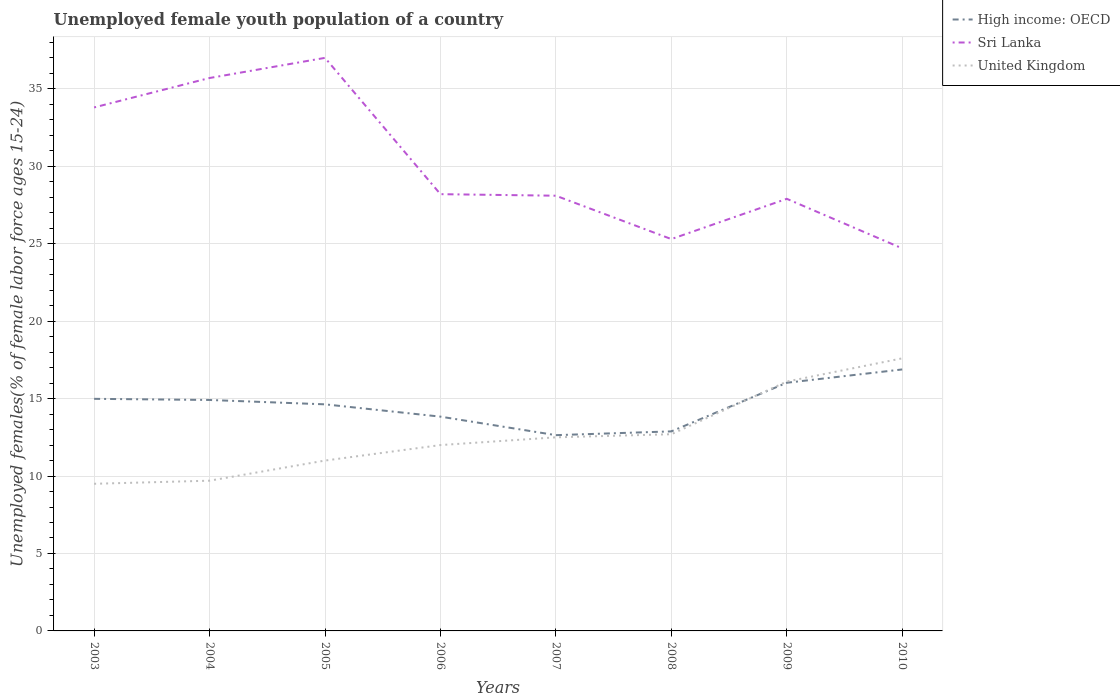Does the line corresponding to United Kingdom intersect with the line corresponding to Sri Lanka?
Offer a terse response. No. Is the number of lines equal to the number of legend labels?
Provide a short and direct response. Yes. Across all years, what is the maximum percentage of unemployed female youth population in United Kingdom?
Provide a succinct answer. 9.5. What is the total percentage of unemployed female youth population in Sri Lanka in the graph?
Make the answer very short. 11. What is the difference between the highest and the second highest percentage of unemployed female youth population in High income: OECD?
Your response must be concise. 4.24. What is the difference between the highest and the lowest percentage of unemployed female youth population in High income: OECD?
Offer a terse response. 5. How many lines are there?
Ensure brevity in your answer.  3. How many years are there in the graph?
Give a very brief answer. 8. What is the difference between two consecutive major ticks on the Y-axis?
Offer a very short reply. 5. Are the values on the major ticks of Y-axis written in scientific E-notation?
Provide a succinct answer. No. Where does the legend appear in the graph?
Give a very brief answer. Top right. What is the title of the graph?
Give a very brief answer. Unemployed female youth population of a country. What is the label or title of the Y-axis?
Make the answer very short. Unemployed females(% of female labor force ages 15-24). What is the Unemployed females(% of female labor force ages 15-24) in High income: OECD in 2003?
Offer a terse response. 14.99. What is the Unemployed females(% of female labor force ages 15-24) in Sri Lanka in 2003?
Make the answer very short. 33.8. What is the Unemployed females(% of female labor force ages 15-24) in United Kingdom in 2003?
Your answer should be compact. 9.5. What is the Unemployed females(% of female labor force ages 15-24) in High income: OECD in 2004?
Your answer should be compact. 14.91. What is the Unemployed females(% of female labor force ages 15-24) of Sri Lanka in 2004?
Provide a succinct answer. 35.7. What is the Unemployed females(% of female labor force ages 15-24) of United Kingdom in 2004?
Provide a succinct answer. 9.7. What is the Unemployed females(% of female labor force ages 15-24) of High income: OECD in 2005?
Offer a terse response. 14.63. What is the Unemployed females(% of female labor force ages 15-24) of Sri Lanka in 2005?
Provide a succinct answer. 37. What is the Unemployed females(% of female labor force ages 15-24) of High income: OECD in 2006?
Ensure brevity in your answer.  13.84. What is the Unemployed females(% of female labor force ages 15-24) in Sri Lanka in 2006?
Give a very brief answer. 28.2. What is the Unemployed females(% of female labor force ages 15-24) of United Kingdom in 2006?
Your answer should be compact. 12. What is the Unemployed females(% of female labor force ages 15-24) in High income: OECD in 2007?
Your answer should be very brief. 12.64. What is the Unemployed females(% of female labor force ages 15-24) in Sri Lanka in 2007?
Make the answer very short. 28.1. What is the Unemployed females(% of female labor force ages 15-24) in High income: OECD in 2008?
Your response must be concise. 12.88. What is the Unemployed females(% of female labor force ages 15-24) in Sri Lanka in 2008?
Your answer should be compact. 25.3. What is the Unemployed females(% of female labor force ages 15-24) of United Kingdom in 2008?
Give a very brief answer. 12.7. What is the Unemployed females(% of female labor force ages 15-24) of High income: OECD in 2009?
Provide a short and direct response. 16.02. What is the Unemployed females(% of female labor force ages 15-24) of Sri Lanka in 2009?
Give a very brief answer. 27.9. What is the Unemployed females(% of female labor force ages 15-24) of United Kingdom in 2009?
Offer a very short reply. 16.1. What is the Unemployed females(% of female labor force ages 15-24) in High income: OECD in 2010?
Provide a short and direct response. 16.88. What is the Unemployed females(% of female labor force ages 15-24) of Sri Lanka in 2010?
Offer a very short reply. 24.7. What is the Unemployed females(% of female labor force ages 15-24) of United Kingdom in 2010?
Ensure brevity in your answer.  17.6. Across all years, what is the maximum Unemployed females(% of female labor force ages 15-24) of High income: OECD?
Your response must be concise. 16.88. Across all years, what is the maximum Unemployed females(% of female labor force ages 15-24) of Sri Lanka?
Offer a terse response. 37. Across all years, what is the maximum Unemployed females(% of female labor force ages 15-24) of United Kingdom?
Your answer should be compact. 17.6. Across all years, what is the minimum Unemployed females(% of female labor force ages 15-24) in High income: OECD?
Provide a succinct answer. 12.64. Across all years, what is the minimum Unemployed females(% of female labor force ages 15-24) in Sri Lanka?
Offer a terse response. 24.7. What is the total Unemployed females(% of female labor force ages 15-24) in High income: OECD in the graph?
Ensure brevity in your answer.  116.79. What is the total Unemployed females(% of female labor force ages 15-24) of Sri Lanka in the graph?
Give a very brief answer. 240.7. What is the total Unemployed females(% of female labor force ages 15-24) of United Kingdom in the graph?
Offer a very short reply. 101.1. What is the difference between the Unemployed females(% of female labor force ages 15-24) in High income: OECD in 2003 and that in 2004?
Provide a short and direct response. 0.07. What is the difference between the Unemployed females(% of female labor force ages 15-24) in High income: OECD in 2003 and that in 2005?
Provide a succinct answer. 0.36. What is the difference between the Unemployed females(% of female labor force ages 15-24) in High income: OECD in 2003 and that in 2006?
Your answer should be very brief. 1.15. What is the difference between the Unemployed females(% of female labor force ages 15-24) of Sri Lanka in 2003 and that in 2006?
Provide a short and direct response. 5.6. What is the difference between the Unemployed females(% of female labor force ages 15-24) of United Kingdom in 2003 and that in 2006?
Ensure brevity in your answer.  -2.5. What is the difference between the Unemployed females(% of female labor force ages 15-24) in High income: OECD in 2003 and that in 2007?
Give a very brief answer. 2.35. What is the difference between the Unemployed females(% of female labor force ages 15-24) in High income: OECD in 2003 and that in 2008?
Offer a very short reply. 2.1. What is the difference between the Unemployed females(% of female labor force ages 15-24) in High income: OECD in 2003 and that in 2009?
Provide a short and direct response. -1.04. What is the difference between the Unemployed females(% of female labor force ages 15-24) of Sri Lanka in 2003 and that in 2009?
Offer a very short reply. 5.9. What is the difference between the Unemployed females(% of female labor force ages 15-24) of United Kingdom in 2003 and that in 2009?
Offer a terse response. -6.6. What is the difference between the Unemployed females(% of female labor force ages 15-24) in High income: OECD in 2003 and that in 2010?
Your answer should be very brief. -1.9. What is the difference between the Unemployed females(% of female labor force ages 15-24) of Sri Lanka in 2003 and that in 2010?
Offer a very short reply. 9.1. What is the difference between the Unemployed females(% of female labor force ages 15-24) in United Kingdom in 2003 and that in 2010?
Give a very brief answer. -8.1. What is the difference between the Unemployed females(% of female labor force ages 15-24) of High income: OECD in 2004 and that in 2005?
Give a very brief answer. 0.28. What is the difference between the Unemployed females(% of female labor force ages 15-24) in United Kingdom in 2004 and that in 2005?
Your answer should be very brief. -1.3. What is the difference between the Unemployed females(% of female labor force ages 15-24) of High income: OECD in 2004 and that in 2006?
Your answer should be compact. 1.08. What is the difference between the Unemployed females(% of female labor force ages 15-24) in United Kingdom in 2004 and that in 2006?
Offer a very short reply. -2.3. What is the difference between the Unemployed females(% of female labor force ages 15-24) of High income: OECD in 2004 and that in 2007?
Ensure brevity in your answer.  2.27. What is the difference between the Unemployed females(% of female labor force ages 15-24) of Sri Lanka in 2004 and that in 2007?
Provide a succinct answer. 7.6. What is the difference between the Unemployed females(% of female labor force ages 15-24) in High income: OECD in 2004 and that in 2008?
Offer a very short reply. 2.03. What is the difference between the Unemployed females(% of female labor force ages 15-24) in Sri Lanka in 2004 and that in 2008?
Make the answer very short. 10.4. What is the difference between the Unemployed females(% of female labor force ages 15-24) of High income: OECD in 2004 and that in 2009?
Your answer should be compact. -1.11. What is the difference between the Unemployed females(% of female labor force ages 15-24) of Sri Lanka in 2004 and that in 2009?
Your response must be concise. 7.8. What is the difference between the Unemployed females(% of female labor force ages 15-24) of United Kingdom in 2004 and that in 2009?
Offer a terse response. -6.4. What is the difference between the Unemployed females(% of female labor force ages 15-24) in High income: OECD in 2004 and that in 2010?
Ensure brevity in your answer.  -1.97. What is the difference between the Unemployed females(% of female labor force ages 15-24) of Sri Lanka in 2004 and that in 2010?
Your answer should be very brief. 11. What is the difference between the Unemployed females(% of female labor force ages 15-24) in United Kingdom in 2004 and that in 2010?
Your answer should be compact. -7.9. What is the difference between the Unemployed females(% of female labor force ages 15-24) of High income: OECD in 2005 and that in 2006?
Your answer should be very brief. 0.79. What is the difference between the Unemployed females(% of female labor force ages 15-24) of United Kingdom in 2005 and that in 2006?
Your response must be concise. -1. What is the difference between the Unemployed females(% of female labor force ages 15-24) of High income: OECD in 2005 and that in 2007?
Offer a very short reply. 1.99. What is the difference between the Unemployed females(% of female labor force ages 15-24) of Sri Lanka in 2005 and that in 2007?
Offer a terse response. 8.9. What is the difference between the Unemployed females(% of female labor force ages 15-24) of United Kingdom in 2005 and that in 2007?
Provide a succinct answer. -1.5. What is the difference between the Unemployed females(% of female labor force ages 15-24) in High income: OECD in 2005 and that in 2008?
Provide a succinct answer. 1.75. What is the difference between the Unemployed females(% of female labor force ages 15-24) of Sri Lanka in 2005 and that in 2008?
Your response must be concise. 11.7. What is the difference between the Unemployed females(% of female labor force ages 15-24) in United Kingdom in 2005 and that in 2008?
Provide a short and direct response. -1.7. What is the difference between the Unemployed females(% of female labor force ages 15-24) in High income: OECD in 2005 and that in 2009?
Your response must be concise. -1.39. What is the difference between the Unemployed females(% of female labor force ages 15-24) in High income: OECD in 2005 and that in 2010?
Provide a succinct answer. -2.25. What is the difference between the Unemployed females(% of female labor force ages 15-24) of Sri Lanka in 2005 and that in 2010?
Provide a succinct answer. 12.3. What is the difference between the Unemployed females(% of female labor force ages 15-24) in High income: OECD in 2006 and that in 2007?
Make the answer very short. 1.2. What is the difference between the Unemployed females(% of female labor force ages 15-24) in United Kingdom in 2006 and that in 2007?
Make the answer very short. -0.5. What is the difference between the Unemployed females(% of female labor force ages 15-24) in High income: OECD in 2006 and that in 2008?
Give a very brief answer. 0.95. What is the difference between the Unemployed females(% of female labor force ages 15-24) of High income: OECD in 2006 and that in 2009?
Make the answer very short. -2.19. What is the difference between the Unemployed females(% of female labor force ages 15-24) of Sri Lanka in 2006 and that in 2009?
Your answer should be very brief. 0.3. What is the difference between the Unemployed females(% of female labor force ages 15-24) of United Kingdom in 2006 and that in 2009?
Your response must be concise. -4.1. What is the difference between the Unemployed females(% of female labor force ages 15-24) of High income: OECD in 2006 and that in 2010?
Make the answer very short. -3.05. What is the difference between the Unemployed females(% of female labor force ages 15-24) in Sri Lanka in 2006 and that in 2010?
Keep it short and to the point. 3.5. What is the difference between the Unemployed females(% of female labor force ages 15-24) of High income: OECD in 2007 and that in 2008?
Give a very brief answer. -0.24. What is the difference between the Unemployed females(% of female labor force ages 15-24) of High income: OECD in 2007 and that in 2009?
Ensure brevity in your answer.  -3.38. What is the difference between the Unemployed females(% of female labor force ages 15-24) in Sri Lanka in 2007 and that in 2009?
Offer a very short reply. 0.2. What is the difference between the Unemployed females(% of female labor force ages 15-24) in United Kingdom in 2007 and that in 2009?
Make the answer very short. -3.6. What is the difference between the Unemployed females(% of female labor force ages 15-24) in High income: OECD in 2007 and that in 2010?
Your answer should be compact. -4.24. What is the difference between the Unemployed females(% of female labor force ages 15-24) in Sri Lanka in 2007 and that in 2010?
Provide a short and direct response. 3.4. What is the difference between the Unemployed females(% of female labor force ages 15-24) in United Kingdom in 2007 and that in 2010?
Your answer should be compact. -5.1. What is the difference between the Unemployed females(% of female labor force ages 15-24) in High income: OECD in 2008 and that in 2009?
Your response must be concise. -3.14. What is the difference between the Unemployed females(% of female labor force ages 15-24) in Sri Lanka in 2008 and that in 2009?
Your answer should be very brief. -2.6. What is the difference between the Unemployed females(% of female labor force ages 15-24) of High income: OECD in 2008 and that in 2010?
Ensure brevity in your answer.  -4. What is the difference between the Unemployed females(% of female labor force ages 15-24) in High income: OECD in 2009 and that in 2010?
Make the answer very short. -0.86. What is the difference between the Unemployed females(% of female labor force ages 15-24) in Sri Lanka in 2009 and that in 2010?
Keep it short and to the point. 3.2. What is the difference between the Unemployed females(% of female labor force ages 15-24) of High income: OECD in 2003 and the Unemployed females(% of female labor force ages 15-24) of Sri Lanka in 2004?
Your answer should be compact. -20.71. What is the difference between the Unemployed females(% of female labor force ages 15-24) in High income: OECD in 2003 and the Unemployed females(% of female labor force ages 15-24) in United Kingdom in 2004?
Offer a terse response. 5.29. What is the difference between the Unemployed females(% of female labor force ages 15-24) in Sri Lanka in 2003 and the Unemployed females(% of female labor force ages 15-24) in United Kingdom in 2004?
Offer a terse response. 24.1. What is the difference between the Unemployed females(% of female labor force ages 15-24) of High income: OECD in 2003 and the Unemployed females(% of female labor force ages 15-24) of Sri Lanka in 2005?
Provide a short and direct response. -22.01. What is the difference between the Unemployed females(% of female labor force ages 15-24) in High income: OECD in 2003 and the Unemployed females(% of female labor force ages 15-24) in United Kingdom in 2005?
Keep it short and to the point. 3.99. What is the difference between the Unemployed females(% of female labor force ages 15-24) of Sri Lanka in 2003 and the Unemployed females(% of female labor force ages 15-24) of United Kingdom in 2005?
Offer a very short reply. 22.8. What is the difference between the Unemployed females(% of female labor force ages 15-24) of High income: OECD in 2003 and the Unemployed females(% of female labor force ages 15-24) of Sri Lanka in 2006?
Your response must be concise. -13.21. What is the difference between the Unemployed females(% of female labor force ages 15-24) of High income: OECD in 2003 and the Unemployed females(% of female labor force ages 15-24) of United Kingdom in 2006?
Give a very brief answer. 2.99. What is the difference between the Unemployed females(% of female labor force ages 15-24) of Sri Lanka in 2003 and the Unemployed females(% of female labor force ages 15-24) of United Kingdom in 2006?
Offer a very short reply. 21.8. What is the difference between the Unemployed females(% of female labor force ages 15-24) of High income: OECD in 2003 and the Unemployed females(% of female labor force ages 15-24) of Sri Lanka in 2007?
Offer a terse response. -13.11. What is the difference between the Unemployed females(% of female labor force ages 15-24) in High income: OECD in 2003 and the Unemployed females(% of female labor force ages 15-24) in United Kingdom in 2007?
Offer a very short reply. 2.49. What is the difference between the Unemployed females(% of female labor force ages 15-24) in Sri Lanka in 2003 and the Unemployed females(% of female labor force ages 15-24) in United Kingdom in 2007?
Your response must be concise. 21.3. What is the difference between the Unemployed females(% of female labor force ages 15-24) of High income: OECD in 2003 and the Unemployed females(% of female labor force ages 15-24) of Sri Lanka in 2008?
Provide a short and direct response. -10.31. What is the difference between the Unemployed females(% of female labor force ages 15-24) of High income: OECD in 2003 and the Unemployed females(% of female labor force ages 15-24) of United Kingdom in 2008?
Offer a terse response. 2.29. What is the difference between the Unemployed females(% of female labor force ages 15-24) in Sri Lanka in 2003 and the Unemployed females(% of female labor force ages 15-24) in United Kingdom in 2008?
Provide a succinct answer. 21.1. What is the difference between the Unemployed females(% of female labor force ages 15-24) of High income: OECD in 2003 and the Unemployed females(% of female labor force ages 15-24) of Sri Lanka in 2009?
Your answer should be very brief. -12.91. What is the difference between the Unemployed females(% of female labor force ages 15-24) of High income: OECD in 2003 and the Unemployed females(% of female labor force ages 15-24) of United Kingdom in 2009?
Your answer should be very brief. -1.11. What is the difference between the Unemployed females(% of female labor force ages 15-24) in Sri Lanka in 2003 and the Unemployed females(% of female labor force ages 15-24) in United Kingdom in 2009?
Your answer should be compact. 17.7. What is the difference between the Unemployed females(% of female labor force ages 15-24) of High income: OECD in 2003 and the Unemployed females(% of female labor force ages 15-24) of Sri Lanka in 2010?
Give a very brief answer. -9.71. What is the difference between the Unemployed females(% of female labor force ages 15-24) of High income: OECD in 2003 and the Unemployed females(% of female labor force ages 15-24) of United Kingdom in 2010?
Make the answer very short. -2.61. What is the difference between the Unemployed females(% of female labor force ages 15-24) of Sri Lanka in 2003 and the Unemployed females(% of female labor force ages 15-24) of United Kingdom in 2010?
Keep it short and to the point. 16.2. What is the difference between the Unemployed females(% of female labor force ages 15-24) of High income: OECD in 2004 and the Unemployed females(% of female labor force ages 15-24) of Sri Lanka in 2005?
Your answer should be very brief. -22.09. What is the difference between the Unemployed females(% of female labor force ages 15-24) in High income: OECD in 2004 and the Unemployed females(% of female labor force ages 15-24) in United Kingdom in 2005?
Provide a succinct answer. 3.91. What is the difference between the Unemployed females(% of female labor force ages 15-24) of Sri Lanka in 2004 and the Unemployed females(% of female labor force ages 15-24) of United Kingdom in 2005?
Your answer should be compact. 24.7. What is the difference between the Unemployed females(% of female labor force ages 15-24) of High income: OECD in 2004 and the Unemployed females(% of female labor force ages 15-24) of Sri Lanka in 2006?
Provide a succinct answer. -13.29. What is the difference between the Unemployed females(% of female labor force ages 15-24) of High income: OECD in 2004 and the Unemployed females(% of female labor force ages 15-24) of United Kingdom in 2006?
Your answer should be compact. 2.91. What is the difference between the Unemployed females(% of female labor force ages 15-24) of Sri Lanka in 2004 and the Unemployed females(% of female labor force ages 15-24) of United Kingdom in 2006?
Give a very brief answer. 23.7. What is the difference between the Unemployed females(% of female labor force ages 15-24) of High income: OECD in 2004 and the Unemployed females(% of female labor force ages 15-24) of Sri Lanka in 2007?
Your answer should be very brief. -13.19. What is the difference between the Unemployed females(% of female labor force ages 15-24) in High income: OECD in 2004 and the Unemployed females(% of female labor force ages 15-24) in United Kingdom in 2007?
Your response must be concise. 2.41. What is the difference between the Unemployed females(% of female labor force ages 15-24) of Sri Lanka in 2004 and the Unemployed females(% of female labor force ages 15-24) of United Kingdom in 2007?
Provide a succinct answer. 23.2. What is the difference between the Unemployed females(% of female labor force ages 15-24) of High income: OECD in 2004 and the Unemployed females(% of female labor force ages 15-24) of Sri Lanka in 2008?
Keep it short and to the point. -10.39. What is the difference between the Unemployed females(% of female labor force ages 15-24) in High income: OECD in 2004 and the Unemployed females(% of female labor force ages 15-24) in United Kingdom in 2008?
Offer a very short reply. 2.21. What is the difference between the Unemployed females(% of female labor force ages 15-24) of Sri Lanka in 2004 and the Unemployed females(% of female labor force ages 15-24) of United Kingdom in 2008?
Offer a very short reply. 23. What is the difference between the Unemployed females(% of female labor force ages 15-24) of High income: OECD in 2004 and the Unemployed females(% of female labor force ages 15-24) of Sri Lanka in 2009?
Your answer should be compact. -12.99. What is the difference between the Unemployed females(% of female labor force ages 15-24) of High income: OECD in 2004 and the Unemployed females(% of female labor force ages 15-24) of United Kingdom in 2009?
Offer a terse response. -1.19. What is the difference between the Unemployed females(% of female labor force ages 15-24) of Sri Lanka in 2004 and the Unemployed females(% of female labor force ages 15-24) of United Kingdom in 2009?
Give a very brief answer. 19.6. What is the difference between the Unemployed females(% of female labor force ages 15-24) in High income: OECD in 2004 and the Unemployed females(% of female labor force ages 15-24) in Sri Lanka in 2010?
Your response must be concise. -9.79. What is the difference between the Unemployed females(% of female labor force ages 15-24) in High income: OECD in 2004 and the Unemployed females(% of female labor force ages 15-24) in United Kingdom in 2010?
Your answer should be very brief. -2.69. What is the difference between the Unemployed females(% of female labor force ages 15-24) of High income: OECD in 2005 and the Unemployed females(% of female labor force ages 15-24) of Sri Lanka in 2006?
Your answer should be very brief. -13.57. What is the difference between the Unemployed females(% of female labor force ages 15-24) of High income: OECD in 2005 and the Unemployed females(% of female labor force ages 15-24) of United Kingdom in 2006?
Keep it short and to the point. 2.63. What is the difference between the Unemployed females(% of female labor force ages 15-24) in High income: OECD in 2005 and the Unemployed females(% of female labor force ages 15-24) in Sri Lanka in 2007?
Your response must be concise. -13.47. What is the difference between the Unemployed females(% of female labor force ages 15-24) of High income: OECD in 2005 and the Unemployed females(% of female labor force ages 15-24) of United Kingdom in 2007?
Give a very brief answer. 2.13. What is the difference between the Unemployed females(% of female labor force ages 15-24) of Sri Lanka in 2005 and the Unemployed females(% of female labor force ages 15-24) of United Kingdom in 2007?
Make the answer very short. 24.5. What is the difference between the Unemployed females(% of female labor force ages 15-24) of High income: OECD in 2005 and the Unemployed females(% of female labor force ages 15-24) of Sri Lanka in 2008?
Offer a very short reply. -10.67. What is the difference between the Unemployed females(% of female labor force ages 15-24) in High income: OECD in 2005 and the Unemployed females(% of female labor force ages 15-24) in United Kingdom in 2008?
Provide a succinct answer. 1.93. What is the difference between the Unemployed females(% of female labor force ages 15-24) of Sri Lanka in 2005 and the Unemployed females(% of female labor force ages 15-24) of United Kingdom in 2008?
Your answer should be compact. 24.3. What is the difference between the Unemployed females(% of female labor force ages 15-24) of High income: OECD in 2005 and the Unemployed females(% of female labor force ages 15-24) of Sri Lanka in 2009?
Provide a succinct answer. -13.27. What is the difference between the Unemployed females(% of female labor force ages 15-24) in High income: OECD in 2005 and the Unemployed females(% of female labor force ages 15-24) in United Kingdom in 2009?
Your answer should be very brief. -1.47. What is the difference between the Unemployed females(% of female labor force ages 15-24) in Sri Lanka in 2005 and the Unemployed females(% of female labor force ages 15-24) in United Kingdom in 2009?
Keep it short and to the point. 20.9. What is the difference between the Unemployed females(% of female labor force ages 15-24) in High income: OECD in 2005 and the Unemployed females(% of female labor force ages 15-24) in Sri Lanka in 2010?
Offer a terse response. -10.07. What is the difference between the Unemployed females(% of female labor force ages 15-24) in High income: OECD in 2005 and the Unemployed females(% of female labor force ages 15-24) in United Kingdom in 2010?
Provide a short and direct response. -2.97. What is the difference between the Unemployed females(% of female labor force ages 15-24) in Sri Lanka in 2005 and the Unemployed females(% of female labor force ages 15-24) in United Kingdom in 2010?
Give a very brief answer. 19.4. What is the difference between the Unemployed females(% of female labor force ages 15-24) in High income: OECD in 2006 and the Unemployed females(% of female labor force ages 15-24) in Sri Lanka in 2007?
Make the answer very short. -14.26. What is the difference between the Unemployed females(% of female labor force ages 15-24) in High income: OECD in 2006 and the Unemployed females(% of female labor force ages 15-24) in United Kingdom in 2007?
Make the answer very short. 1.34. What is the difference between the Unemployed females(% of female labor force ages 15-24) of Sri Lanka in 2006 and the Unemployed females(% of female labor force ages 15-24) of United Kingdom in 2007?
Provide a succinct answer. 15.7. What is the difference between the Unemployed females(% of female labor force ages 15-24) in High income: OECD in 2006 and the Unemployed females(% of female labor force ages 15-24) in Sri Lanka in 2008?
Keep it short and to the point. -11.46. What is the difference between the Unemployed females(% of female labor force ages 15-24) in High income: OECD in 2006 and the Unemployed females(% of female labor force ages 15-24) in United Kingdom in 2008?
Your response must be concise. 1.14. What is the difference between the Unemployed females(% of female labor force ages 15-24) of Sri Lanka in 2006 and the Unemployed females(% of female labor force ages 15-24) of United Kingdom in 2008?
Provide a succinct answer. 15.5. What is the difference between the Unemployed females(% of female labor force ages 15-24) of High income: OECD in 2006 and the Unemployed females(% of female labor force ages 15-24) of Sri Lanka in 2009?
Make the answer very short. -14.06. What is the difference between the Unemployed females(% of female labor force ages 15-24) of High income: OECD in 2006 and the Unemployed females(% of female labor force ages 15-24) of United Kingdom in 2009?
Your answer should be very brief. -2.26. What is the difference between the Unemployed females(% of female labor force ages 15-24) in Sri Lanka in 2006 and the Unemployed females(% of female labor force ages 15-24) in United Kingdom in 2009?
Give a very brief answer. 12.1. What is the difference between the Unemployed females(% of female labor force ages 15-24) of High income: OECD in 2006 and the Unemployed females(% of female labor force ages 15-24) of Sri Lanka in 2010?
Make the answer very short. -10.86. What is the difference between the Unemployed females(% of female labor force ages 15-24) in High income: OECD in 2006 and the Unemployed females(% of female labor force ages 15-24) in United Kingdom in 2010?
Your answer should be very brief. -3.76. What is the difference between the Unemployed females(% of female labor force ages 15-24) of Sri Lanka in 2006 and the Unemployed females(% of female labor force ages 15-24) of United Kingdom in 2010?
Your answer should be very brief. 10.6. What is the difference between the Unemployed females(% of female labor force ages 15-24) in High income: OECD in 2007 and the Unemployed females(% of female labor force ages 15-24) in Sri Lanka in 2008?
Give a very brief answer. -12.66. What is the difference between the Unemployed females(% of female labor force ages 15-24) of High income: OECD in 2007 and the Unemployed females(% of female labor force ages 15-24) of United Kingdom in 2008?
Ensure brevity in your answer.  -0.06. What is the difference between the Unemployed females(% of female labor force ages 15-24) in Sri Lanka in 2007 and the Unemployed females(% of female labor force ages 15-24) in United Kingdom in 2008?
Ensure brevity in your answer.  15.4. What is the difference between the Unemployed females(% of female labor force ages 15-24) in High income: OECD in 2007 and the Unemployed females(% of female labor force ages 15-24) in Sri Lanka in 2009?
Keep it short and to the point. -15.26. What is the difference between the Unemployed females(% of female labor force ages 15-24) of High income: OECD in 2007 and the Unemployed females(% of female labor force ages 15-24) of United Kingdom in 2009?
Make the answer very short. -3.46. What is the difference between the Unemployed females(% of female labor force ages 15-24) in Sri Lanka in 2007 and the Unemployed females(% of female labor force ages 15-24) in United Kingdom in 2009?
Your answer should be very brief. 12. What is the difference between the Unemployed females(% of female labor force ages 15-24) in High income: OECD in 2007 and the Unemployed females(% of female labor force ages 15-24) in Sri Lanka in 2010?
Provide a succinct answer. -12.06. What is the difference between the Unemployed females(% of female labor force ages 15-24) in High income: OECD in 2007 and the Unemployed females(% of female labor force ages 15-24) in United Kingdom in 2010?
Your answer should be compact. -4.96. What is the difference between the Unemployed females(% of female labor force ages 15-24) of High income: OECD in 2008 and the Unemployed females(% of female labor force ages 15-24) of Sri Lanka in 2009?
Your answer should be very brief. -15.02. What is the difference between the Unemployed females(% of female labor force ages 15-24) of High income: OECD in 2008 and the Unemployed females(% of female labor force ages 15-24) of United Kingdom in 2009?
Your answer should be compact. -3.22. What is the difference between the Unemployed females(% of female labor force ages 15-24) in Sri Lanka in 2008 and the Unemployed females(% of female labor force ages 15-24) in United Kingdom in 2009?
Provide a short and direct response. 9.2. What is the difference between the Unemployed females(% of female labor force ages 15-24) of High income: OECD in 2008 and the Unemployed females(% of female labor force ages 15-24) of Sri Lanka in 2010?
Provide a short and direct response. -11.82. What is the difference between the Unemployed females(% of female labor force ages 15-24) of High income: OECD in 2008 and the Unemployed females(% of female labor force ages 15-24) of United Kingdom in 2010?
Your response must be concise. -4.72. What is the difference between the Unemployed females(% of female labor force ages 15-24) of High income: OECD in 2009 and the Unemployed females(% of female labor force ages 15-24) of Sri Lanka in 2010?
Your answer should be compact. -8.68. What is the difference between the Unemployed females(% of female labor force ages 15-24) of High income: OECD in 2009 and the Unemployed females(% of female labor force ages 15-24) of United Kingdom in 2010?
Your answer should be compact. -1.58. What is the difference between the Unemployed females(% of female labor force ages 15-24) in Sri Lanka in 2009 and the Unemployed females(% of female labor force ages 15-24) in United Kingdom in 2010?
Give a very brief answer. 10.3. What is the average Unemployed females(% of female labor force ages 15-24) in High income: OECD per year?
Make the answer very short. 14.6. What is the average Unemployed females(% of female labor force ages 15-24) of Sri Lanka per year?
Your answer should be compact. 30.09. What is the average Unemployed females(% of female labor force ages 15-24) in United Kingdom per year?
Provide a succinct answer. 12.64. In the year 2003, what is the difference between the Unemployed females(% of female labor force ages 15-24) in High income: OECD and Unemployed females(% of female labor force ages 15-24) in Sri Lanka?
Offer a terse response. -18.81. In the year 2003, what is the difference between the Unemployed females(% of female labor force ages 15-24) in High income: OECD and Unemployed females(% of female labor force ages 15-24) in United Kingdom?
Offer a terse response. 5.49. In the year 2003, what is the difference between the Unemployed females(% of female labor force ages 15-24) in Sri Lanka and Unemployed females(% of female labor force ages 15-24) in United Kingdom?
Provide a short and direct response. 24.3. In the year 2004, what is the difference between the Unemployed females(% of female labor force ages 15-24) in High income: OECD and Unemployed females(% of female labor force ages 15-24) in Sri Lanka?
Make the answer very short. -20.79. In the year 2004, what is the difference between the Unemployed females(% of female labor force ages 15-24) in High income: OECD and Unemployed females(% of female labor force ages 15-24) in United Kingdom?
Your response must be concise. 5.21. In the year 2004, what is the difference between the Unemployed females(% of female labor force ages 15-24) in Sri Lanka and Unemployed females(% of female labor force ages 15-24) in United Kingdom?
Your answer should be very brief. 26. In the year 2005, what is the difference between the Unemployed females(% of female labor force ages 15-24) of High income: OECD and Unemployed females(% of female labor force ages 15-24) of Sri Lanka?
Offer a terse response. -22.37. In the year 2005, what is the difference between the Unemployed females(% of female labor force ages 15-24) in High income: OECD and Unemployed females(% of female labor force ages 15-24) in United Kingdom?
Give a very brief answer. 3.63. In the year 2006, what is the difference between the Unemployed females(% of female labor force ages 15-24) in High income: OECD and Unemployed females(% of female labor force ages 15-24) in Sri Lanka?
Offer a very short reply. -14.36. In the year 2006, what is the difference between the Unemployed females(% of female labor force ages 15-24) of High income: OECD and Unemployed females(% of female labor force ages 15-24) of United Kingdom?
Provide a short and direct response. 1.84. In the year 2006, what is the difference between the Unemployed females(% of female labor force ages 15-24) of Sri Lanka and Unemployed females(% of female labor force ages 15-24) of United Kingdom?
Provide a short and direct response. 16.2. In the year 2007, what is the difference between the Unemployed females(% of female labor force ages 15-24) of High income: OECD and Unemployed females(% of female labor force ages 15-24) of Sri Lanka?
Ensure brevity in your answer.  -15.46. In the year 2007, what is the difference between the Unemployed females(% of female labor force ages 15-24) in High income: OECD and Unemployed females(% of female labor force ages 15-24) in United Kingdom?
Offer a terse response. 0.14. In the year 2007, what is the difference between the Unemployed females(% of female labor force ages 15-24) of Sri Lanka and Unemployed females(% of female labor force ages 15-24) of United Kingdom?
Make the answer very short. 15.6. In the year 2008, what is the difference between the Unemployed females(% of female labor force ages 15-24) in High income: OECD and Unemployed females(% of female labor force ages 15-24) in Sri Lanka?
Your response must be concise. -12.42. In the year 2008, what is the difference between the Unemployed females(% of female labor force ages 15-24) in High income: OECD and Unemployed females(% of female labor force ages 15-24) in United Kingdom?
Provide a short and direct response. 0.18. In the year 2009, what is the difference between the Unemployed females(% of female labor force ages 15-24) in High income: OECD and Unemployed females(% of female labor force ages 15-24) in Sri Lanka?
Give a very brief answer. -11.88. In the year 2009, what is the difference between the Unemployed females(% of female labor force ages 15-24) in High income: OECD and Unemployed females(% of female labor force ages 15-24) in United Kingdom?
Ensure brevity in your answer.  -0.08. In the year 2009, what is the difference between the Unemployed females(% of female labor force ages 15-24) of Sri Lanka and Unemployed females(% of female labor force ages 15-24) of United Kingdom?
Make the answer very short. 11.8. In the year 2010, what is the difference between the Unemployed females(% of female labor force ages 15-24) of High income: OECD and Unemployed females(% of female labor force ages 15-24) of Sri Lanka?
Offer a very short reply. -7.82. In the year 2010, what is the difference between the Unemployed females(% of female labor force ages 15-24) in High income: OECD and Unemployed females(% of female labor force ages 15-24) in United Kingdom?
Your answer should be compact. -0.72. In the year 2010, what is the difference between the Unemployed females(% of female labor force ages 15-24) in Sri Lanka and Unemployed females(% of female labor force ages 15-24) in United Kingdom?
Your answer should be compact. 7.1. What is the ratio of the Unemployed females(% of female labor force ages 15-24) in Sri Lanka in 2003 to that in 2004?
Provide a succinct answer. 0.95. What is the ratio of the Unemployed females(% of female labor force ages 15-24) of United Kingdom in 2003 to that in 2004?
Your answer should be very brief. 0.98. What is the ratio of the Unemployed females(% of female labor force ages 15-24) of High income: OECD in 2003 to that in 2005?
Offer a very short reply. 1.02. What is the ratio of the Unemployed females(% of female labor force ages 15-24) in Sri Lanka in 2003 to that in 2005?
Your response must be concise. 0.91. What is the ratio of the Unemployed females(% of female labor force ages 15-24) in United Kingdom in 2003 to that in 2005?
Offer a terse response. 0.86. What is the ratio of the Unemployed females(% of female labor force ages 15-24) of High income: OECD in 2003 to that in 2006?
Provide a succinct answer. 1.08. What is the ratio of the Unemployed females(% of female labor force ages 15-24) of Sri Lanka in 2003 to that in 2006?
Offer a terse response. 1.2. What is the ratio of the Unemployed females(% of female labor force ages 15-24) of United Kingdom in 2003 to that in 2006?
Offer a very short reply. 0.79. What is the ratio of the Unemployed females(% of female labor force ages 15-24) in High income: OECD in 2003 to that in 2007?
Ensure brevity in your answer.  1.19. What is the ratio of the Unemployed females(% of female labor force ages 15-24) of Sri Lanka in 2003 to that in 2007?
Offer a terse response. 1.2. What is the ratio of the Unemployed females(% of female labor force ages 15-24) of United Kingdom in 2003 to that in 2007?
Make the answer very short. 0.76. What is the ratio of the Unemployed females(% of female labor force ages 15-24) of High income: OECD in 2003 to that in 2008?
Your answer should be very brief. 1.16. What is the ratio of the Unemployed females(% of female labor force ages 15-24) of Sri Lanka in 2003 to that in 2008?
Provide a short and direct response. 1.34. What is the ratio of the Unemployed females(% of female labor force ages 15-24) in United Kingdom in 2003 to that in 2008?
Make the answer very short. 0.75. What is the ratio of the Unemployed females(% of female labor force ages 15-24) in High income: OECD in 2003 to that in 2009?
Your response must be concise. 0.94. What is the ratio of the Unemployed females(% of female labor force ages 15-24) of Sri Lanka in 2003 to that in 2009?
Offer a very short reply. 1.21. What is the ratio of the Unemployed females(% of female labor force ages 15-24) of United Kingdom in 2003 to that in 2009?
Offer a terse response. 0.59. What is the ratio of the Unemployed females(% of female labor force ages 15-24) in High income: OECD in 2003 to that in 2010?
Give a very brief answer. 0.89. What is the ratio of the Unemployed females(% of female labor force ages 15-24) of Sri Lanka in 2003 to that in 2010?
Your answer should be compact. 1.37. What is the ratio of the Unemployed females(% of female labor force ages 15-24) of United Kingdom in 2003 to that in 2010?
Your answer should be compact. 0.54. What is the ratio of the Unemployed females(% of female labor force ages 15-24) of High income: OECD in 2004 to that in 2005?
Provide a short and direct response. 1.02. What is the ratio of the Unemployed females(% of female labor force ages 15-24) of Sri Lanka in 2004 to that in 2005?
Your answer should be compact. 0.96. What is the ratio of the Unemployed females(% of female labor force ages 15-24) of United Kingdom in 2004 to that in 2005?
Make the answer very short. 0.88. What is the ratio of the Unemployed females(% of female labor force ages 15-24) in High income: OECD in 2004 to that in 2006?
Ensure brevity in your answer.  1.08. What is the ratio of the Unemployed females(% of female labor force ages 15-24) of Sri Lanka in 2004 to that in 2006?
Your answer should be compact. 1.27. What is the ratio of the Unemployed females(% of female labor force ages 15-24) in United Kingdom in 2004 to that in 2006?
Offer a terse response. 0.81. What is the ratio of the Unemployed females(% of female labor force ages 15-24) of High income: OECD in 2004 to that in 2007?
Keep it short and to the point. 1.18. What is the ratio of the Unemployed females(% of female labor force ages 15-24) of Sri Lanka in 2004 to that in 2007?
Provide a short and direct response. 1.27. What is the ratio of the Unemployed females(% of female labor force ages 15-24) of United Kingdom in 2004 to that in 2007?
Your response must be concise. 0.78. What is the ratio of the Unemployed females(% of female labor force ages 15-24) of High income: OECD in 2004 to that in 2008?
Make the answer very short. 1.16. What is the ratio of the Unemployed females(% of female labor force ages 15-24) of Sri Lanka in 2004 to that in 2008?
Your answer should be compact. 1.41. What is the ratio of the Unemployed females(% of female labor force ages 15-24) of United Kingdom in 2004 to that in 2008?
Your response must be concise. 0.76. What is the ratio of the Unemployed females(% of female labor force ages 15-24) in High income: OECD in 2004 to that in 2009?
Offer a very short reply. 0.93. What is the ratio of the Unemployed females(% of female labor force ages 15-24) of Sri Lanka in 2004 to that in 2009?
Give a very brief answer. 1.28. What is the ratio of the Unemployed females(% of female labor force ages 15-24) in United Kingdom in 2004 to that in 2009?
Make the answer very short. 0.6. What is the ratio of the Unemployed females(% of female labor force ages 15-24) in High income: OECD in 2004 to that in 2010?
Provide a succinct answer. 0.88. What is the ratio of the Unemployed females(% of female labor force ages 15-24) in Sri Lanka in 2004 to that in 2010?
Your response must be concise. 1.45. What is the ratio of the Unemployed females(% of female labor force ages 15-24) in United Kingdom in 2004 to that in 2010?
Your answer should be compact. 0.55. What is the ratio of the Unemployed females(% of female labor force ages 15-24) in High income: OECD in 2005 to that in 2006?
Give a very brief answer. 1.06. What is the ratio of the Unemployed females(% of female labor force ages 15-24) in Sri Lanka in 2005 to that in 2006?
Your response must be concise. 1.31. What is the ratio of the Unemployed females(% of female labor force ages 15-24) of United Kingdom in 2005 to that in 2006?
Offer a terse response. 0.92. What is the ratio of the Unemployed females(% of female labor force ages 15-24) in High income: OECD in 2005 to that in 2007?
Offer a terse response. 1.16. What is the ratio of the Unemployed females(% of female labor force ages 15-24) of Sri Lanka in 2005 to that in 2007?
Offer a terse response. 1.32. What is the ratio of the Unemployed females(% of female labor force ages 15-24) of High income: OECD in 2005 to that in 2008?
Provide a short and direct response. 1.14. What is the ratio of the Unemployed females(% of female labor force ages 15-24) in Sri Lanka in 2005 to that in 2008?
Your response must be concise. 1.46. What is the ratio of the Unemployed females(% of female labor force ages 15-24) in United Kingdom in 2005 to that in 2008?
Your answer should be very brief. 0.87. What is the ratio of the Unemployed females(% of female labor force ages 15-24) of High income: OECD in 2005 to that in 2009?
Provide a succinct answer. 0.91. What is the ratio of the Unemployed females(% of female labor force ages 15-24) in Sri Lanka in 2005 to that in 2009?
Your answer should be compact. 1.33. What is the ratio of the Unemployed females(% of female labor force ages 15-24) in United Kingdom in 2005 to that in 2009?
Your answer should be very brief. 0.68. What is the ratio of the Unemployed females(% of female labor force ages 15-24) of High income: OECD in 2005 to that in 2010?
Offer a very short reply. 0.87. What is the ratio of the Unemployed females(% of female labor force ages 15-24) in Sri Lanka in 2005 to that in 2010?
Make the answer very short. 1.5. What is the ratio of the Unemployed females(% of female labor force ages 15-24) in United Kingdom in 2005 to that in 2010?
Keep it short and to the point. 0.62. What is the ratio of the Unemployed females(% of female labor force ages 15-24) in High income: OECD in 2006 to that in 2007?
Provide a succinct answer. 1.09. What is the ratio of the Unemployed females(% of female labor force ages 15-24) of United Kingdom in 2006 to that in 2007?
Make the answer very short. 0.96. What is the ratio of the Unemployed females(% of female labor force ages 15-24) of High income: OECD in 2006 to that in 2008?
Keep it short and to the point. 1.07. What is the ratio of the Unemployed females(% of female labor force ages 15-24) in Sri Lanka in 2006 to that in 2008?
Make the answer very short. 1.11. What is the ratio of the Unemployed females(% of female labor force ages 15-24) in United Kingdom in 2006 to that in 2008?
Make the answer very short. 0.94. What is the ratio of the Unemployed females(% of female labor force ages 15-24) of High income: OECD in 2006 to that in 2009?
Provide a short and direct response. 0.86. What is the ratio of the Unemployed females(% of female labor force ages 15-24) in Sri Lanka in 2006 to that in 2009?
Offer a terse response. 1.01. What is the ratio of the Unemployed females(% of female labor force ages 15-24) of United Kingdom in 2006 to that in 2009?
Your answer should be compact. 0.75. What is the ratio of the Unemployed females(% of female labor force ages 15-24) in High income: OECD in 2006 to that in 2010?
Your answer should be compact. 0.82. What is the ratio of the Unemployed females(% of female labor force ages 15-24) of Sri Lanka in 2006 to that in 2010?
Make the answer very short. 1.14. What is the ratio of the Unemployed females(% of female labor force ages 15-24) in United Kingdom in 2006 to that in 2010?
Offer a terse response. 0.68. What is the ratio of the Unemployed females(% of female labor force ages 15-24) of High income: OECD in 2007 to that in 2008?
Provide a short and direct response. 0.98. What is the ratio of the Unemployed females(% of female labor force ages 15-24) in Sri Lanka in 2007 to that in 2008?
Ensure brevity in your answer.  1.11. What is the ratio of the Unemployed females(% of female labor force ages 15-24) of United Kingdom in 2007 to that in 2008?
Make the answer very short. 0.98. What is the ratio of the Unemployed females(% of female labor force ages 15-24) of High income: OECD in 2007 to that in 2009?
Give a very brief answer. 0.79. What is the ratio of the Unemployed females(% of female labor force ages 15-24) of Sri Lanka in 2007 to that in 2009?
Your answer should be compact. 1.01. What is the ratio of the Unemployed females(% of female labor force ages 15-24) in United Kingdom in 2007 to that in 2009?
Your answer should be very brief. 0.78. What is the ratio of the Unemployed females(% of female labor force ages 15-24) of High income: OECD in 2007 to that in 2010?
Provide a short and direct response. 0.75. What is the ratio of the Unemployed females(% of female labor force ages 15-24) of Sri Lanka in 2007 to that in 2010?
Keep it short and to the point. 1.14. What is the ratio of the Unemployed females(% of female labor force ages 15-24) of United Kingdom in 2007 to that in 2010?
Provide a succinct answer. 0.71. What is the ratio of the Unemployed females(% of female labor force ages 15-24) in High income: OECD in 2008 to that in 2009?
Keep it short and to the point. 0.8. What is the ratio of the Unemployed females(% of female labor force ages 15-24) in Sri Lanka in 2008 to that in 2009?
Your answer should be very brief. 0.91. What is the ratio of the Unemployed females(% of female labor force ages 15-24) of United Kingdom in 2008 to that in 2009?
Your answer should be compact. 0.79. What is the ratio of the Unemployed females(% of female labor force ages 15-24) of High income: OECD in 2008 to that in 2010?
Make the answer very short. 0.76. What is the ratio of the Unemployed females(% of female labor force ages 15-24) in Sri Lanka in 2008 to that in 2010?
Offer a terse response. 1.02. What is the ratio of the Unemployed females(% of female labor force ages 15-24) of United Kingdom in 2008 to that in 2010?
Give a very brief answer. 0.72. What is the ratio of the Unemployed females(% of female labor force ages 15-24) in High income: OECD in 2009 to that in 2010?
Ensure brevity in your answer.  0.95. What is the ratio of the Unemployed females(% of female labor force ages 15-24) of Sri Lanka in 2009 to that in 2010?
Keep it short and to the point. 1.13. What is the ratio of the Unemployed females(% of female labor force ages 15-24) in United Kingdom in 2009 to that in 2010?
Offer a very short reply. 0.91. What is the difference between the highest and the second highest Unemployed females(% of female labor force ages 15-24) in High income: OECD?
Offer a very short reply. 0.86. What is the difference between the highest and the lowest Unemployed females(% of female labor force ages 15-24) of High income: OECD?
Offer a terse response. 4.24. What is the difference between the highest and the lowest Unemployed females(% of female labor force ages 15-24) in United Kingdom?
Your answer should be compact. 8.1. 